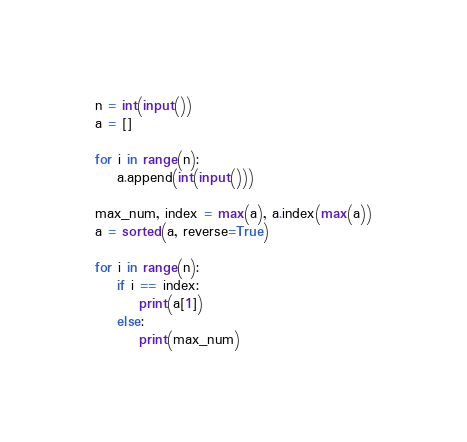Convert code to text. <code><loc_0><loc_0><loc_500><loc_500><_Python_>n = int(input())
a = []

for i in range(n):
    a.append(int(input()))

max_num, index = max(a), a.index(max(a))
a = sorted(a, reverse=True)

for i in range(n):
    if i == index:
        print(a[1])
    else:
        print(max_num)</code> 